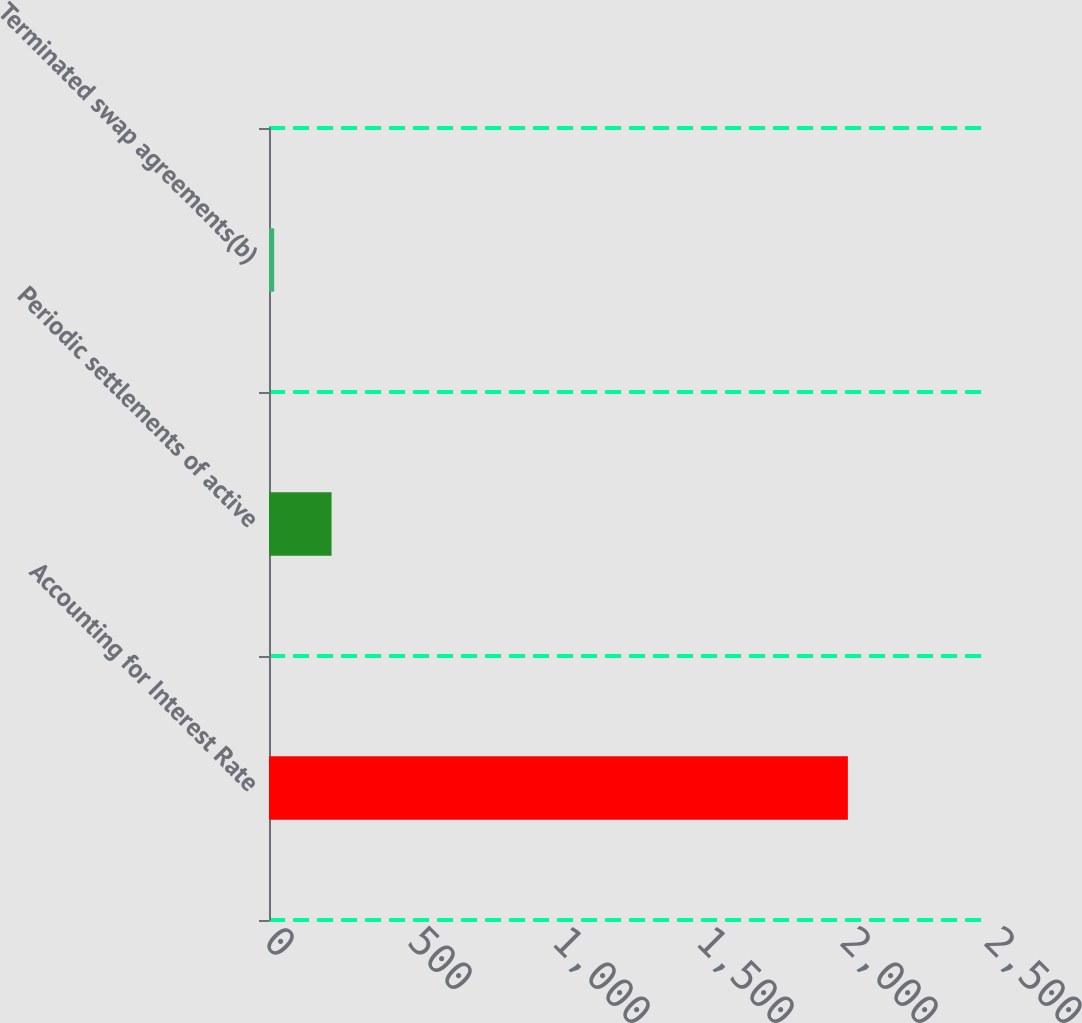Convert chart. <chart><loc_0><loc_0><loc_500><loc_500><bar_chart><fcel>Accounting for Interest Rate<fcel>Periodic settlements of active<fcel>Terminated swap agreements(b)<nl><fcel>2010<fcel>217.2<fcel>18<nl></chart> 